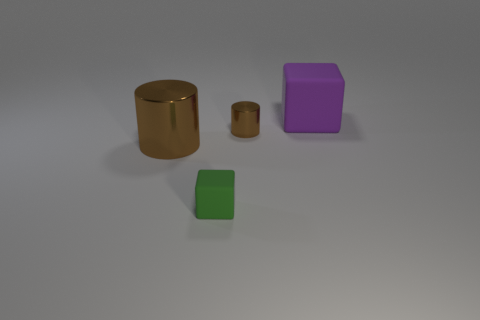What is the cube right of the small rubber thing made of?
Provide a succinct answer. Rubber. There is a tiny brown metallic object; what shape is it?
Keep it short and to the point. Cylinder. There is a big thing that is in front of the purple object; is it the same color as the tiny cylinder?
Provide a succinct answer. Yes. There is a object that is both left of the tiny brown metal thing and right of the big brown cylinder; what is its shape?
Give a very brief answer. Cube. There is a large object that is to the left of the large matte thing; what is its color?
Your answer should be compact. Brown. Is there any other thing that is the same color as the tiny rubber cube?
Your answer should be very brief. No. What size is the thing that is behind the green rubber block and in front of the small metallic cylinder?
Make the answer very short. Large. What number of other big cubes have the same material as the green cube?
Your answer should be compact. 1. What color is the tiny metal object?
Provide a short and direct response. Brown. There is a rubber object on the left side of the purple block; is it the same shape as the big purple rubber thing?
Provide a succinct answer. Yes. 